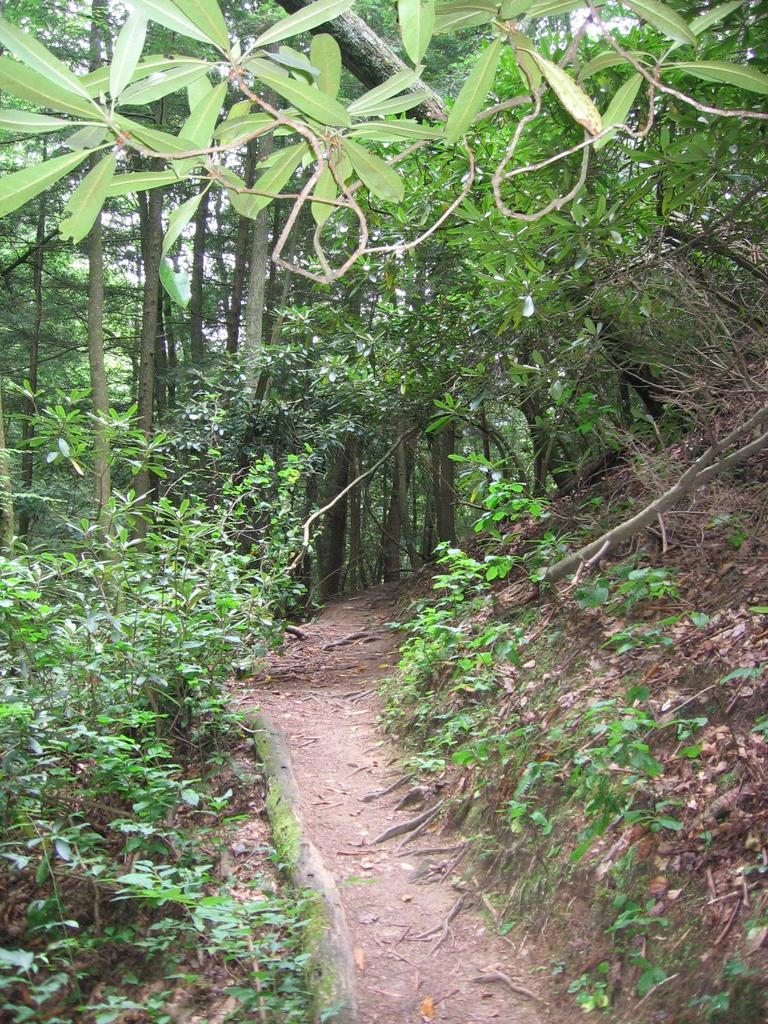Can you describe this image briefly? In this picture I can see many trees, plants and grass. At the top I can see many leaves. In the top left I can see the sky. 